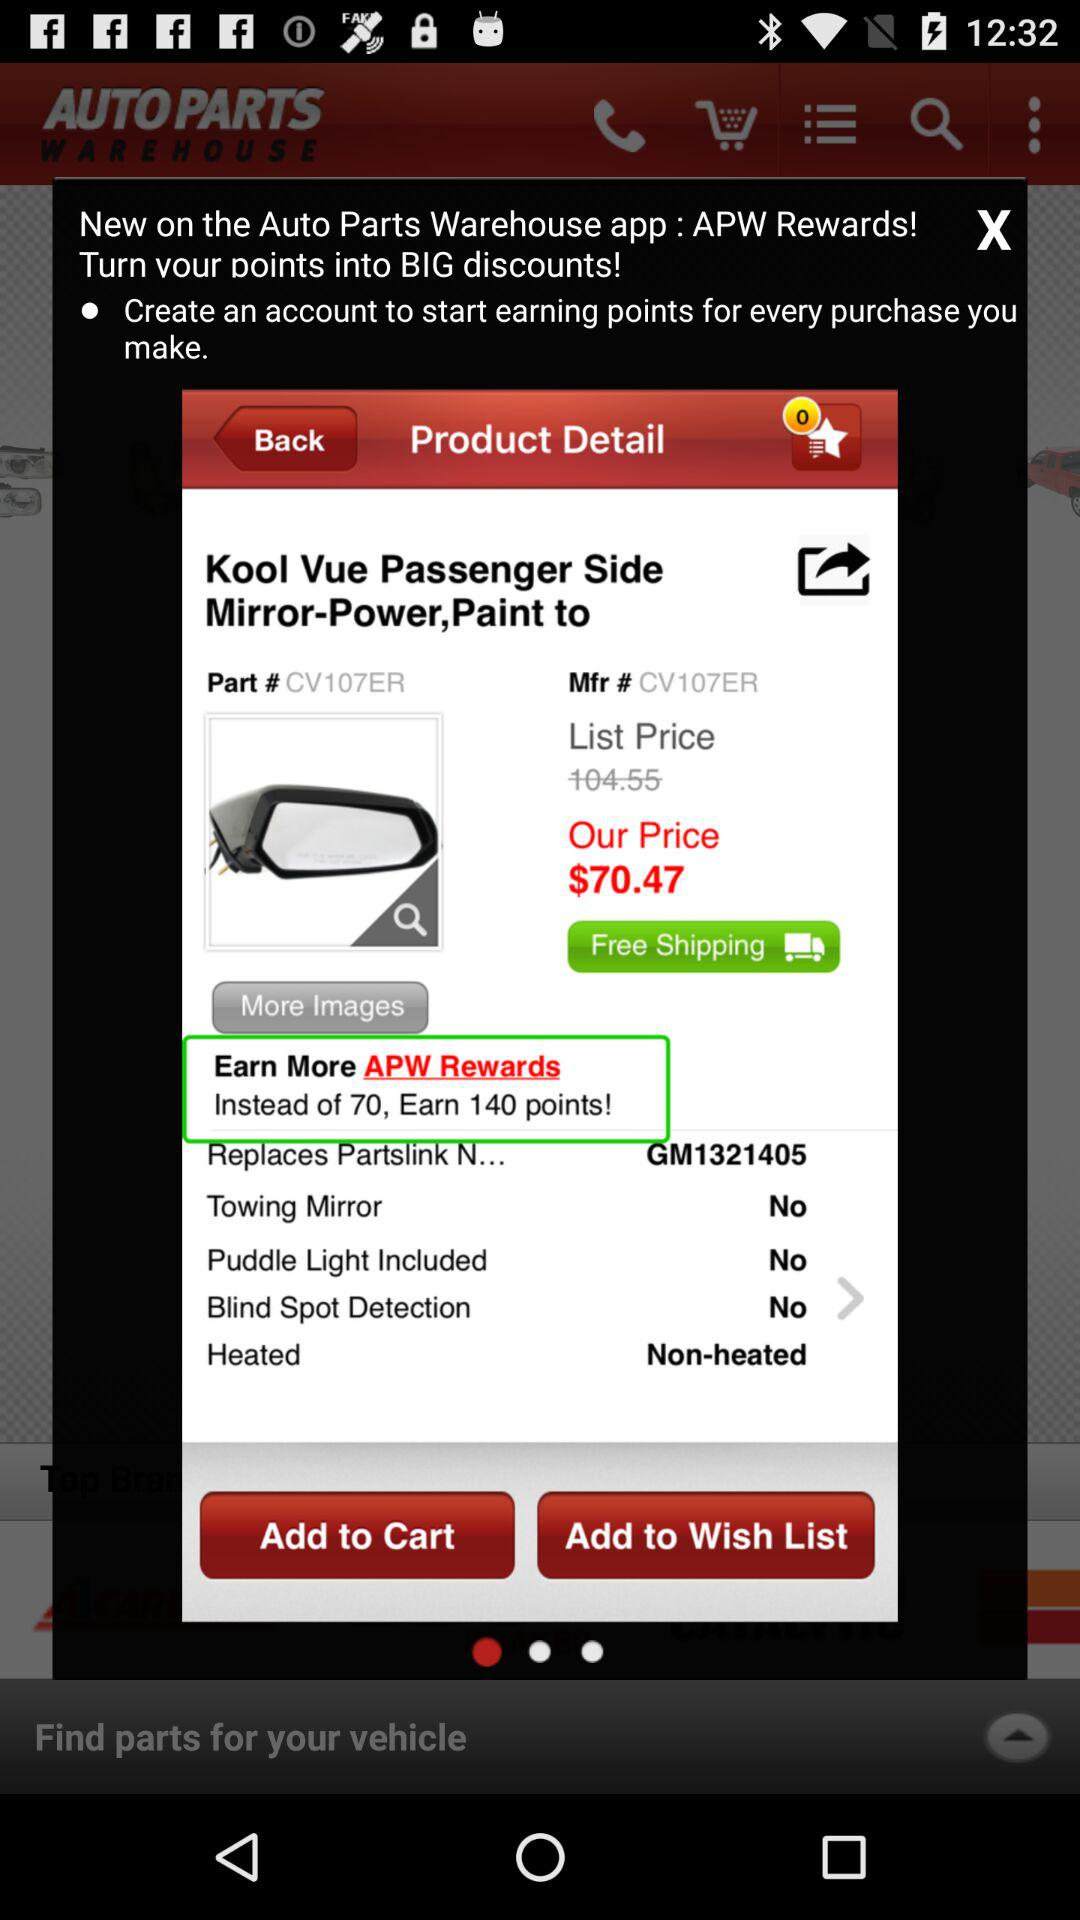How many points can be earned instead of 70? The points that can be earned instead of 70 are 140. 